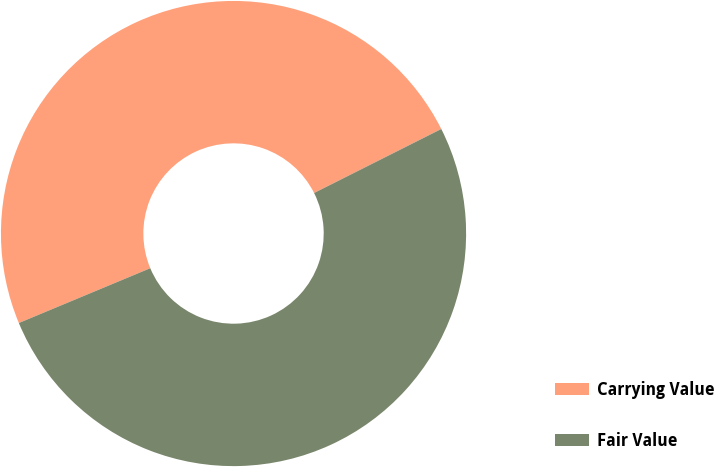<chart> <loc_0><loc_0><loc_500><loc_500><pie_chart><fcel>Carrying Value<fcel>Fair Value<nl><fcel>48.87%<fcel>51.13%<nl></chart> 